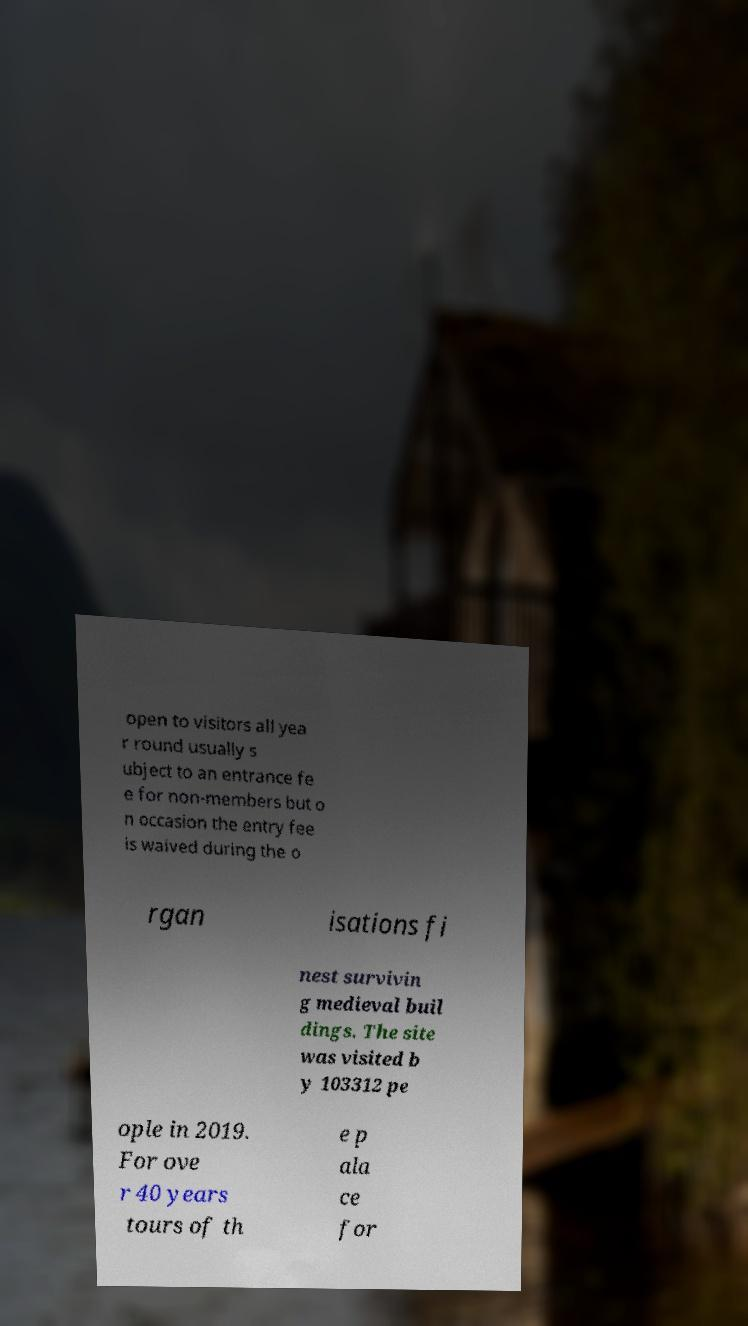Could you extract and type out the text from this image? open to visitors all yea r round usually s ubject to an entrance fe e for non-members but o n occasion the entry fee is waived during the o rgan isations fi nest survivin g medieval buil dings. The site was visited b y 103312 pe ople in 2019. For ove r 40 years tours of th e p ala ce for 